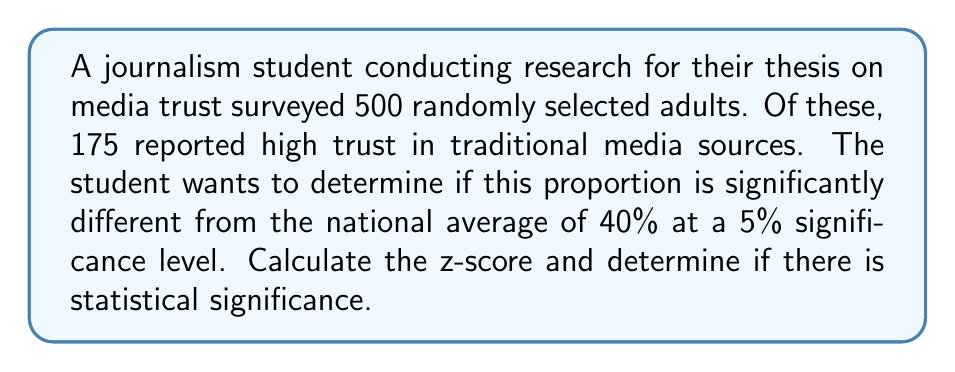Could you help me with this problem? To determine if there is statistical significance, we need to perform a hypothesis test using the z-score. We'll follow these steps:

1. Define the null and alternative hypotheses:
   $H_0: p = 0.40$ (the sample proportion is not significantly different from the national average)
   $H_a: p \neq 0.40$ (the sample proportion is significantly different from the national average)

2. Calculate the sample proportion:
   $\hat{p} = \frac{175}{500} = 0.35$

3. Calculate the standard error of the proportion:
   $SE = \sqrt{\frac{p_0(1-p_0)}{n}} = \sqrt{\frac{0.40(1-0.40)}{500}} = 0.0219$

4. Calculate the z-score:
   $$z = \frac{\hat{p} - p_0}{SE} = \frac{0.35 - 0.40}{0.0219} = -2.28$$

5. Determine the critical value:
   For a two-tailed test at a 5% significance level, the critical z-value is ±1.96.

6. Compare the calculated z-score to the critical value:
   |-2.28| > 1.96, so we reject the null hypothesis.

Therefore, there is statistical significance, and we can conclude that the sample proportion is significantly different from the national average at the 5% significance level.
Answer: z-score = -2.28
There is statistical significance (reject $H_0$) 